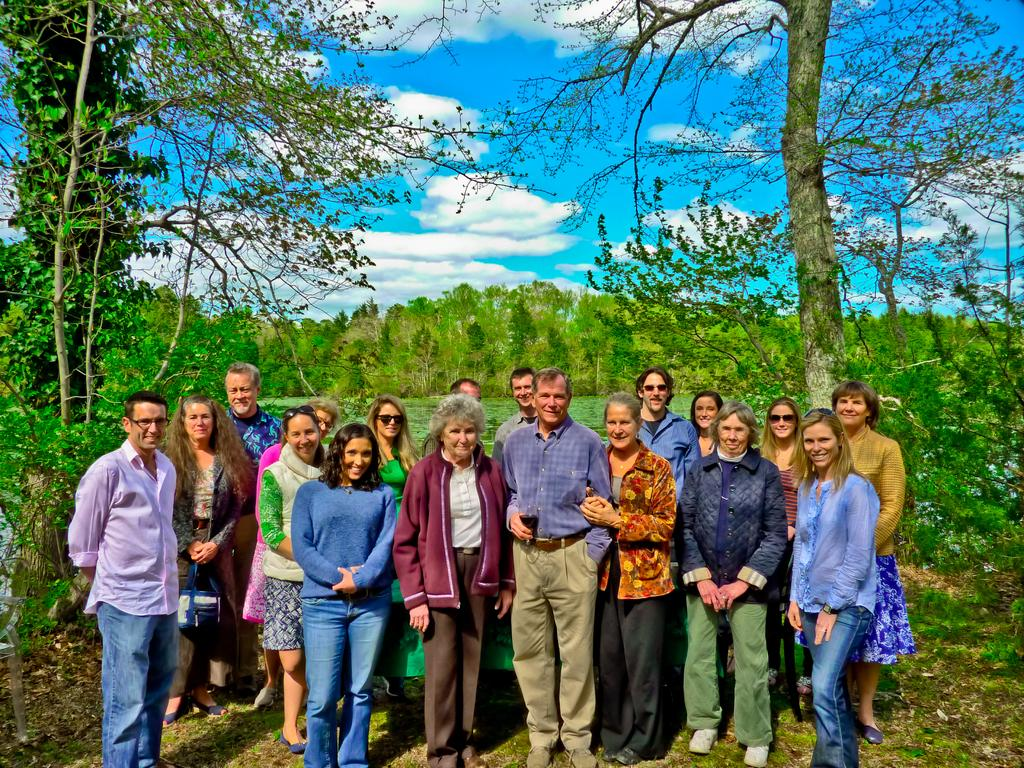Who or what can be seen in the image? There are people in the image. What type of natural elements are present in the image? There are trees and plants in the image. What can be seen in the background of the image? The sky is visible in the background of the image, and it appears to be cloudy. What type of trousers are the people wearing in the image? There is no information about the type of trousers the people are wearing in the image. 